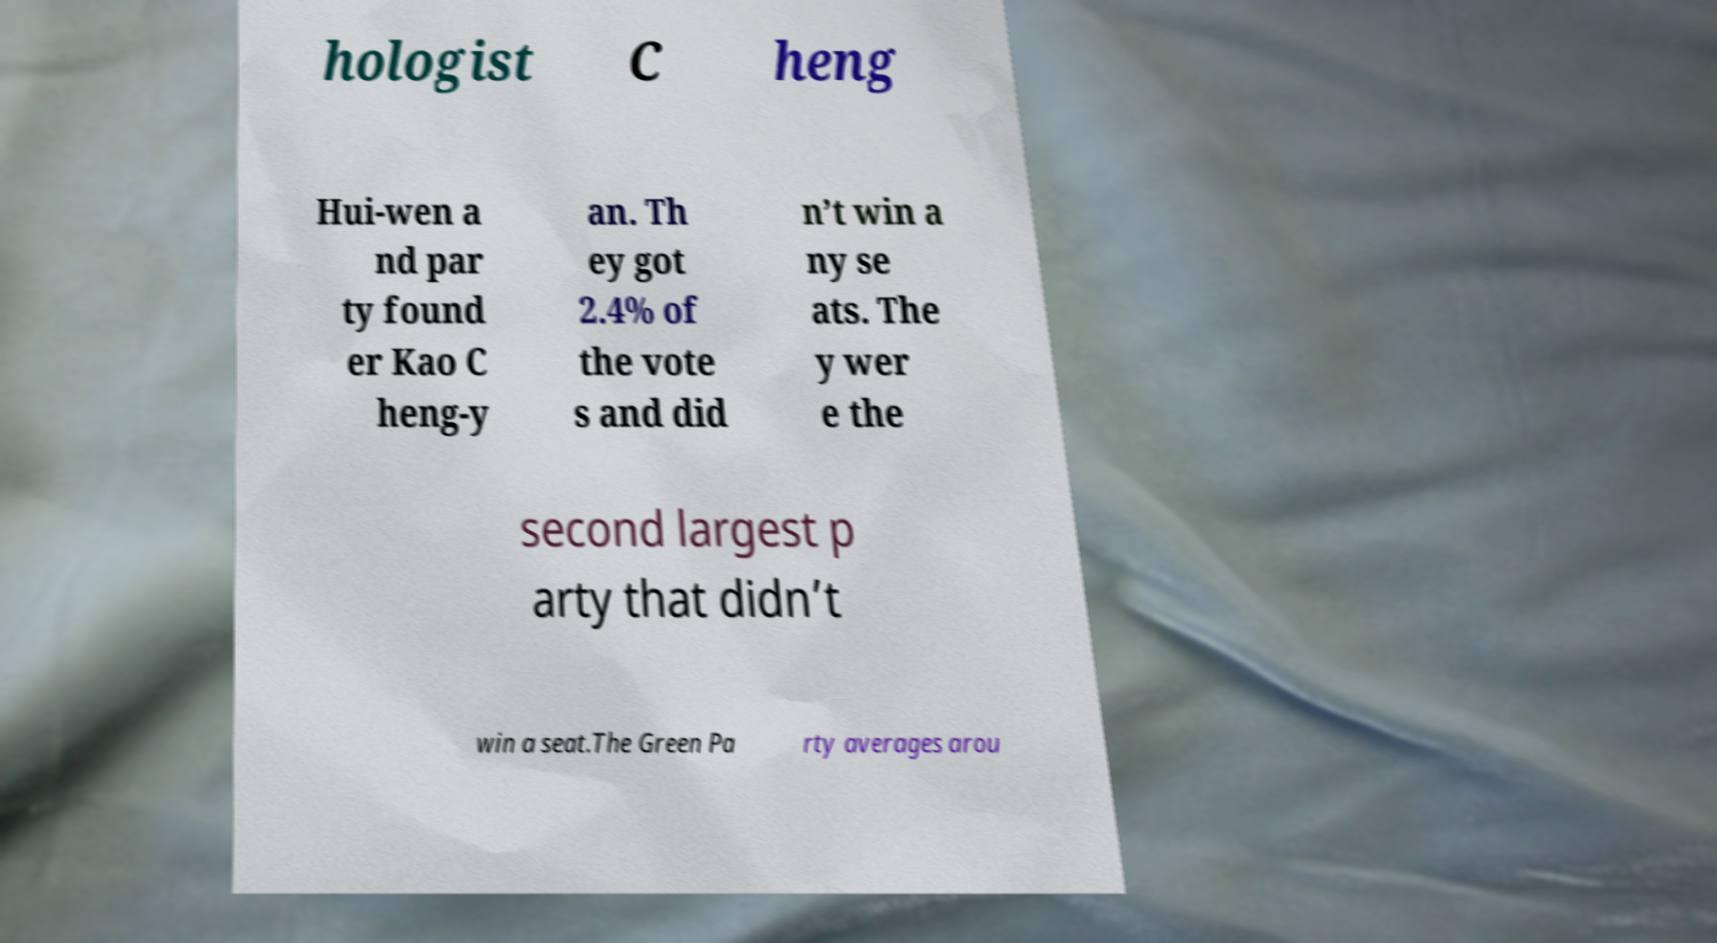I need the written content from this picture converted into text. Can you do that? hologist C heng Hui-wen a nd par ty found er Kao C heng-y an. Th ey got 2.4% of the vote s and did n’t win a ny se ats. The y wer e the second largest p arty that didn’t win a seat.The Green Pa rty averages arou 